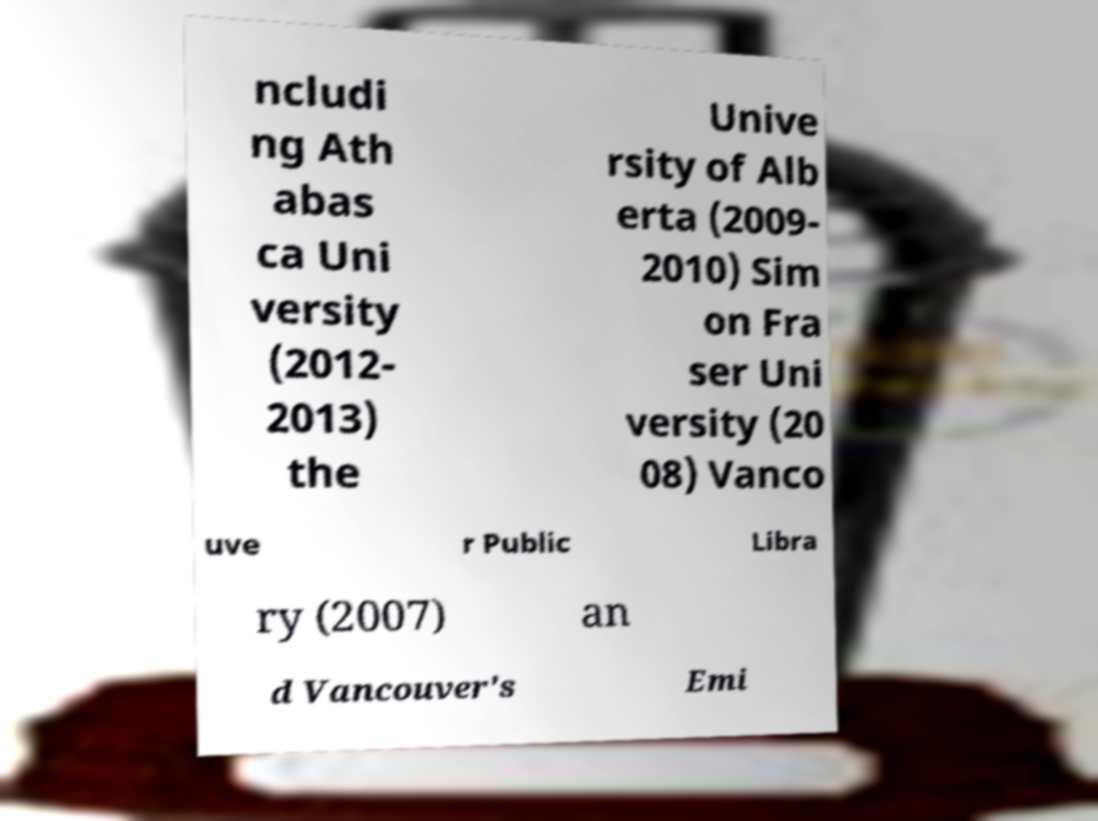Please read and relay the text visible in this image. What does it say? ncludi ng Ath abas ca Uni versity (2012- 2013) the Unive rsity of Alb erta (2009- 2010) Sim on Fra ser Uni versity (20 08) Vanco uve r Public Libra ry (2007) an d Vancouver's Emi 